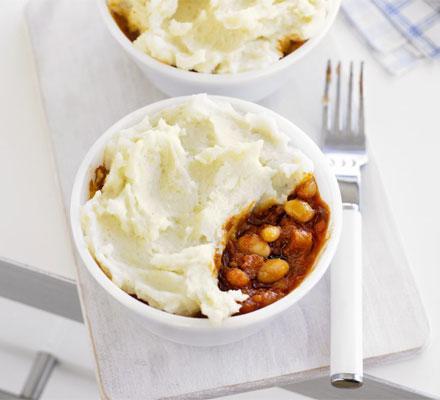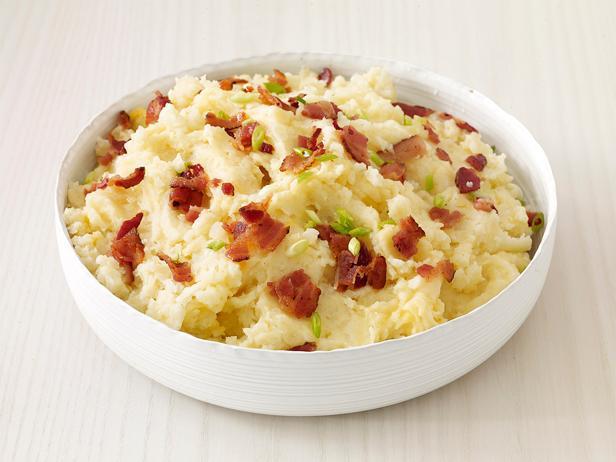The first image is the image on the left, the second image is the image on the right. Analyze the images presented: Is the assertion "One image in the pair has more than one plate or bowl." valid? Answer yes or no. Yes. The first image is the image on the left, the second image is the image on the right. Examine the images to the left and right. Is the description "At least one of the dishes has visible handles" accurate? Answer yes or no. No. 